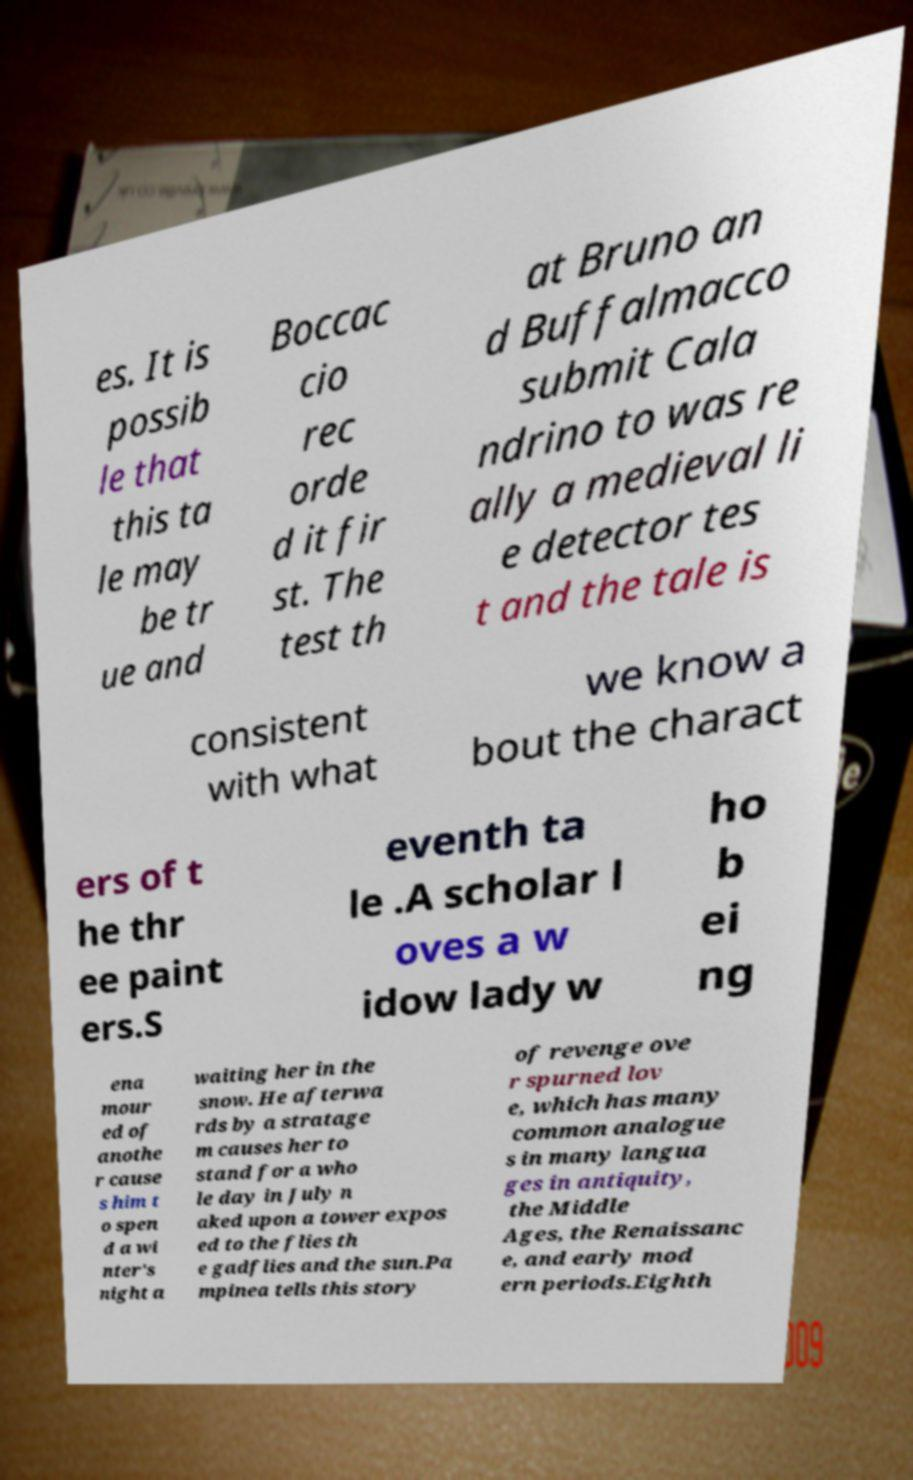Could you extract and type out the text from this image? es. It is possib le that this ta le may be tr ue and Boccac cio rec orde d it fir st. The test th at Bruno an d Buffalmacco submit Cala ndrino to was re ally a medieval li e detector tes t and the tale is consistent with what we know a bout the charact ers of t he thr ee paint ers.S eventh ta le .A scholar l oves a w idow lady w ho b ei ng ena mour ed of anothe r cause s him t o spen d a wi nter's night a waiting her in the snow. He afterwa rds by a stratage m causes her to stand for a who le day in July n aked upon a tower expos ed to the flies th e gadflies and the sun.Pa mpinea tells this story of revenge ove r spurned lov e, which has many common analogue s in many langua ges in antiquity, the Middle Ages, the Renaissanc e, and early mod ern periods.Eighth 